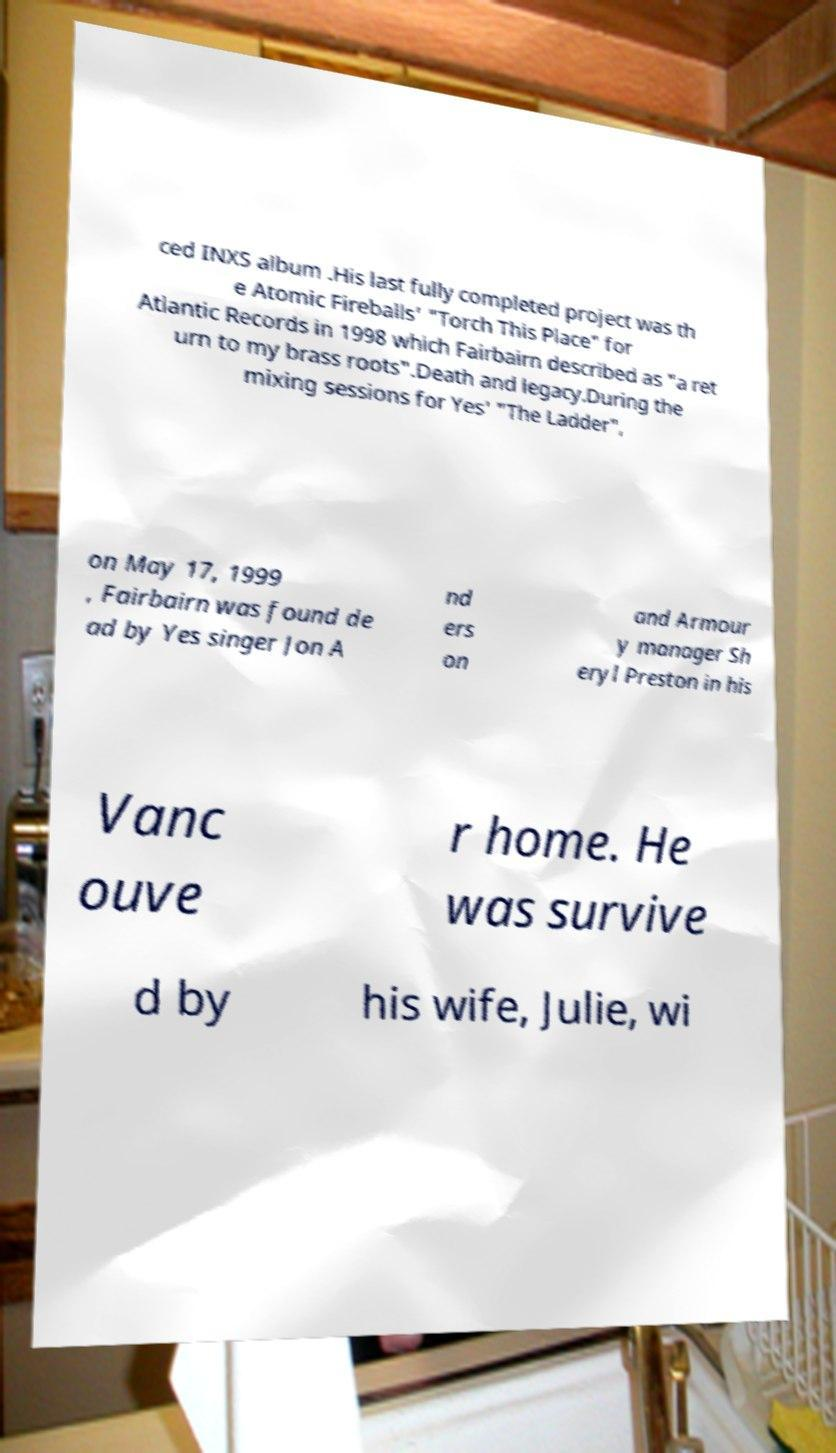For documentation purposes, I need the text within this image transcribed. Could you provide that? ced INXS album .His last fully completed project was th e Atomic Fireballs' "Torch This Place" for Atlantic Records in 1998 which Fairbairn described as "a ret urn to my brass roots".Death and legacy.During the mixing sessions for Yes' "The Ladder", on May 17, 1999 , Fairbairn was found de ad by Yes singer Jon A nd ers on and Armour y manager Sh eryl Preston in his Vanc ouve r home. He was survive d by his wife, Julie, wi 